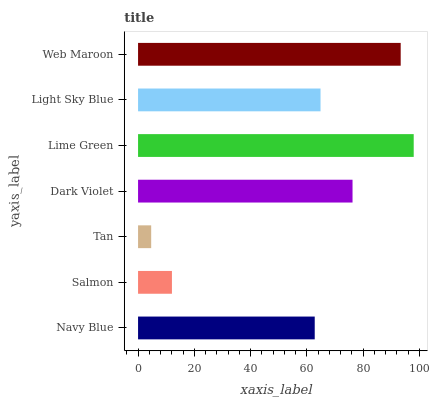Is Tan the minimum?
Answer yes or no. Yes. Is Lime Green the maximum?
Answer yes or no. Yes. Is Salmon the minimum?
Answer yes or no. No. Is Salmon the maximum?
Answer yes or no. No. Is Navy Blue greater than Salmon?
Answer yes or no. Yes. Is Salmon less than Navy Blue?
Answer yes or no. Yes. Is Salmon greater than Navy Blue?
Answer yes or no. No. Is Navy Blue less than Salmon?
Answer yes or no. No. Is Light Sky Blue the high median?
Answer yes or no. Yes. Is Light Sky Blue the low median?
Answer yes or no. Yes. Is Web Maroon the high median?
Answer yes or no. No. Is Navy Blue the low median?
Answer yes or no. No. 